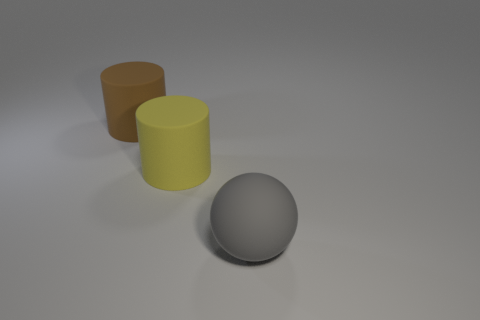There is another matte thing that is the same shape as the yellow matte object; what is its color?
Keep it short and to the point. Brown. Is the number of large gray balls that are left of the brown matte cylinder greater than the number of large brown objects?
Ensure brevity in your answer.  No. The big rubber cylinder in front of the large rubber object behind the yellow matte object is what color?
Your answer should be compact. Yellow. What number of objects are either big objects that are behind the gray rubber sphere or matte spheres that are in front of the brown rubber cylinder?
Your answer should be compact. 3. The ball is what color?
Ensure brevity in your answer.  Gray. What number of big gray balls have the same material as the yellow cylinder?
Ensure brevity in your answer.  1. Is the number of cylinders greater than the number of big gray objects?
Provide a short and direct response. Yes. There is a rubber cylinder in front of the large brown object; how many big things are on the left side of it?
Your answer should be very brief. 1. How many objects are either big things that are to the right of the big brown cylinder or small blue objects?
Provide a succinct answer. 2. Is there a purple rubber thing that has the same shape as the big yellow matte thing?
Your answer should be compact. No. 